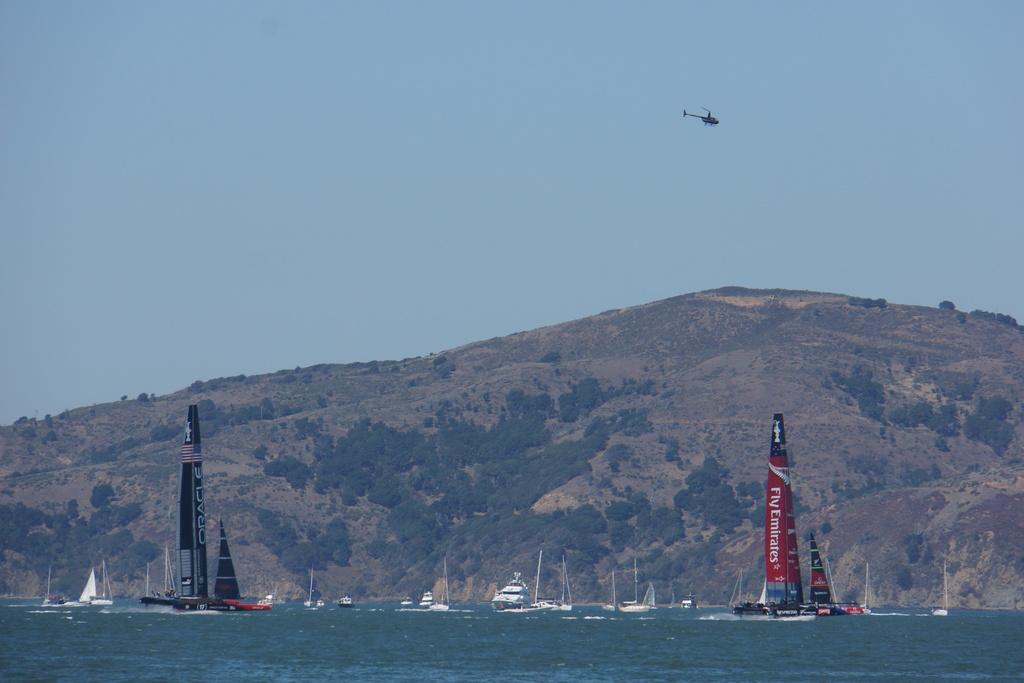What does the sail say?
Provide a short and direct response. Fly emirates. What airline is advertised on the red sail?
Offer a terse response. Fly emirates . 